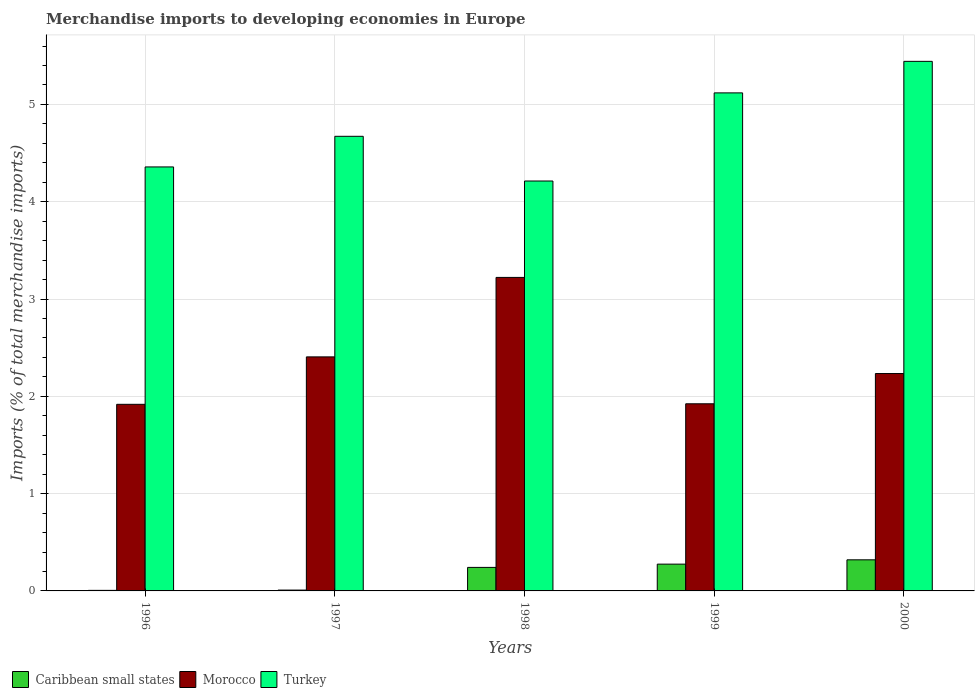How many different coloured bars are there?
Give a very brief answer. 3. How many bars are there on the 5th tick from the right?
Offer a very short reply. 3. What is the percentage total merchandise imports in Morocco in 1999?
Ensure brevity in your answer.  1.92. Across all years, what is the maximum percentage total merchandise imports in Turkey?
Provide a short and direct response. 5.44. Across all years, what is the minimum percentage total merchandise imports in Morocco?
Your response must be concise. 1.92. What is the total percentage total merchandise imports in Turkey in the graph?
Make the answer very short. 23.81. What is the difference between the percentage total merchandise imports in Morocco in 1996 and that in 1997?
Offer a terse response. -0.49. What is the difference between the percentage total merchandise imports in Turkey in 2000 and the percentage total merchandise imports in Morocco in 1999?
Ensure brevity in your answer.  3.52. What is the average percentage total merchandise imports in Morocco per year?
Offer a terse response. 2.34. In the year 1999, what is the difference between the percentage total merchandise imports in Caribbean small states and percentage total merchandise imports in Morocco?
Offer a very short reply. -1.65. In how many years, is the percentage total merchandise imports in Morocco greater than 4 %?
Ensure brevity in your answer.  0. What is the ratio of the percentage total merchandise imports in Turkey in 1996 to that in 1997?
Make the answer very short. 0.93. Is the percentage total merchandise imports in Morocco in 1996 less than that in 1999?
Your answer should be very brief. Yes. Is the difference between the percentage total merchandise imports in Caribbean small states in 1997 and 1999 greater than the difference between the percentage total merchandise imports in Morocco in 1997 and 1999?
Your answer should be very brief. No. What is the difference between the highest and the second highest percentage total merchandise imports in Turkey?
Your response must be concise. 0.32. What is the difference between the highest and the lowest percentage total merchandise imports in Caribbean small states?
Make the answer very short. 0.31. In how many years, is the percentage total merchandise imports in Caribbean small states greater than the average percentage total merchandise imports in Caribbean small states taken over all years?
Give a very brief answer. 3. Is the sum of the percentage total merchandise imports in Morocco in 1996 and 1997 greater than the maximum percentage total merchandise imports in Turkey across all years?
Your response must be concise. No. What does the 1st bar from the left in 2000 represents?
Provide a short and direct response. Caribbean small states. What does the 2nd bar from the right in 1997 represents?
Your response must be concise. Morocco. Is it the case that in every year, the sum of the percentage total merchandise imports in Caribbean small states and percentage total merchandise imports in Turkey is greater than the percentage total merchandise imports in Morocco?
Ensure brevity in your answer.  Yes. How many bars are there?
Offer a very short reply. 15. Are all the bars in the graph horizontal?
Provide a succinct answer. No. How many years are there in the graph?
Provide a succinct answer. 5. What is the difference between two consecutive major ticks on the Y-axis?
Keep it short and to the point. 1. Where does the legend appear in the graph?
Keep it short and to the point. Bottom left. How many legend labels are there?
Provide a short and direct response. 3. How are the legend labels stacked?
Give a very brief answer. Horizontal. What is the title of the graph?
Offer a very short reply. Merchandise imports to developing economies in Europe. Does "Botswana" appear as one of the legend labels in the graph?
Your answer should be very brief. No. What is the label or title of the Y-axis?
Offer a terse response. Imports (% of total merchandise imports). What is the Imports (% of total merchandise imports) in Caribbean small states in 1996?
Give a very brief answer. 0.01. What is the Imports (% of total merchandise imports) of Morocco in 1996?
Make the answer very short. 1.92. What is the Imports (% of total merchandise imports) in Turkey in 1996?
Offer a very short reply. 4.36. What is the Imports (% of total merchandise imports) of Caribbean small states in 1997?
Your response must be concise. 0.01. What is the Imports (% of total merchandise imports) in Morocco in 1997?
Provide a short and direct response. 2.41. What is the Imports (% of total merchandise imports) of Turkey in 1997?
Make the answer very short. 4.67. What is the Imports (% of total merchandise imports) of Caribbean small states in 1998?
Your answer should be very brief. 0.24. What is the Imports (% of total merchandise imports) in Morocco in 1998?
Provide a short and direct response. 3.22. What is the Imports (% of total merchandise imports) in Turkey in 1998?
Provide a succinct answer. 4.21. What is the Imports (% of total merchandise imports) in Caribbean small states in 1999?
Your response must be concise. 0.28. What is the Imports (% of total merchandise imports) of Morocco in 1999?
Your response must be concise. 1.92. What is the Imports (% of total merchandise imports) in Turkey in 1999?
Make the answer very short. 5.12. What is the Imports (% of total merchandise imports) in Caribbean small states in 2000?
Make the answer very short. 0.32. What is the Imports (% of total merchandise imports) in Morocco in 2000?
Your answer should be very brief. 2.23. What is the Imports (% of total merchandise imports) in Turkey in 2000?
Your response must be concise. 5.44. Across all years, what is the maximum Imports (% of total merchandise imports) of Caribbean small states?
Offer a very short reply. 0.32. Across all years, what is the maximum Imports (% of total merchandise imports) in Morocco?
Your response must be concise. 3.22. Across all years, what is the maximum Imports (% of total merchandise imports) of Turkey?
Your answer should be very brief. 5.44. Across all years, what is the minimum Imports (% of total merchandise imports) in Caribbean small states?
Provide a short and direct response. 0.01. Across all years, what is the minimum Imports (% of total merchandise imports) of Morocco?
Your response must be concise. 1.92. Across all years, what is the minimum Imports (% of total merchandise imports) of Turkey?
Offer a very short reply. 4.21. What is the total Imports (% of total merchandise imports) of Caribbean small states in the graph?
Give a very brief answer. 0.85. What is the total Imports (% of total merchandise imports) in Morocco in the graph?
Offer a terse response. 11.7. What is the total Imports (% of total merchandise imports) of Turkey in the graph?
Your response must be concise. 23.81. What is the difference between the Imports (% of total merchandise imports) in Caribbean small states in 1996 and that in 1997?
Your answer should be compact. -0. What is the difference between the Imports (% of total merchandise imports) in Morocco in 1996 and that in 1997?
Your response must be concise. -0.49. What is the difference between the Imports (% of total merchandise imports) in Turkey in 1996 and that in 1997?
Make the answer very short. -0.31. What is the difference between the Imports (% of total merchandise imports) of Caribbean small states in 1996 and that in 1998?
Your answer should be very brief. -0.24. What is the difference between the Imports (% of total merchandise imports) of Morocco in 1996 and that in 1998?
Make the answer very short. -1.3. What is the difference between the Imports (% of total merchandise imports) in Turkey in 1996 and that in 1998?
Your answer should be compact. 0.14. What is the difference between the Imports (% of total merchandise imports) of Caribbean small states in 1996 and that in 1999?
Ensure brevity in your answer.  -0.27. What is the difference between the Imports (% of total merchandise imports) of Morocco in 1996 and that in 1999?
Keep it short and to the point. -0.01. What is the difference between the Imports (% of total merchandise imports) in Turkey in 1996 and that in 1999?
Give a very brief answer. -0.76. What is the difference between the Imports (% of total merchandise imports) of Caribbean small states in 1996 and that in 2000?
Keep it short and to the point. -0.31. What is the difference between the Imports (% of total merchandise imports) of Morocco in 1996 and that in 2000?
Provide a succinct answer. -0.32. What is the difference between the Imports (% of total merchandise imports) of Turkey in 1996 and that in 2000?
Provide a short and direct response. -1.09. What is the difference between the Imports (% of total merchandise imports) in Caribbean small states in 1997 and that in 1998?
Offer a very short reply. -0.23. What is the difference between the Imports (% of total merchandise imports) of Morocco in 1997 and that in 1998?
Your response must be concise. -0.82. What is the difference between the Imports (% of total merchandise imports) of Turkey in 1997 and that in 1998?
Provide a short and direct response. 0.46. What is the difference between the Imports (% of total merchandise imports) in Caribbean small states in 1997 and that in 1999?
Give a very brief answer. -0.27. What is the difference between the Imports (% of total merchandise imports) of Morocco in 1997 and that in 1999?
Offer a terse response. 0.48. What is the difference between the Imports (% of total merchandise imports) of Turkey in 1997 and that in 1999?
Keep it short and to the point. -0.45. What is the difference between the Imports (% of total merchandise imports) of Caribbean small states in 1997 and that in 2000?
Offer a terse response. -0.31. What is the difference between the Imports (% of total merchandise imports) in Morocco in 1997 and that in 2000?
Keep it short and to the point. 0.17. What is the difference between the Imports (% of total merchandise imports) of Turkey in 1997 and that in 2000?
Ensure brevity in your answer.  -0.77. What is the difference between the Imports (% of total merchandise imports) of Caribbean small states in 1998 and that in 1999?
Offer a very short reply. -0.03. What is the difference between the Imports (% of total merchandise imports) in Morocco in 1998 and that in 1999?
Your answer should be compact. 1.3. What is the difference between the Imports (% of total merchandise imports) of Turkey in 1998 and that in 1999?
Make the answer very short. -0.91. What is the difference between the Imports (% of total merchandise imports) in Caribbean small states in 1998 and that in 2000?
Your answer should be very brief. -0.08. What is the difference between the Imports (% of total merchandise imports) in Morocco in 1998 and that in 2000?
Your answer should be compact. 0.99. What is the difference between the Imports (% of total merchandise imports) in Turkey in 1998 and that in 2000?
Your answer should be compact. -1.23. What is the difference between the Imports (% of total merchandise imports) of Caribbean small states in 1999 and that in 2000?
Offer a very short reply. -0.04. What is the difference between the Imports (% of total merchandise imports) in Morocco in 1999 and that in 2000?
Offer a terse response. -0.31. What is the difference between the Imports (% of total merchandise imports) of Turkey in 1999 and that in 2000?
Your response must be concise. -0.32. What is the difference between the Imports (% of total merchandise imports) of Caribbean small states in 1996 and the Imports (% of total merchandise imports) of Morocco in 1997?
Provide a short and direct response. -2.4. What is the difference between the Imports (% of total merchandise imports) of Caribbean small states in 1996 and the Imports (% of total merchandise imports) of Turkey in 1997?
Your response must be concise. -4.67. What is the difference between the Imports (% of total merchandise imports) in Morocco in 1996 and the Imports (% of total merchandise imports) in Turkey in 1997?
Your answer should be very brief. -2.75. What is the difference between the Imports (% of total merchandise imports) in Caribbean small states in 1996 and the Imports (% of total merchandise imports) in Morocco in 1998?
Your answer should be very brief. -3.22. What is the difference between the Imports (% of total merchandise imports) of Caribbean small states in 1996 and the Imports (% of total merchandise imports) of Turkey in 1998?
Keep it short and to the point. -4.21. What is the difference between the Imports (% of total merchandise imports) in Morocco in 1996 and the Imports (% of total merchandise imports) in Turkey in 1998?
Offer a very short reply. -2.3. What is the difference between the Imports (% of total merchandise imports) in Caribbean small states in 1996 and the Imports (% of total merchandise imports) in Morocco in 1999?
Ensure brevity in your answer.  -1.92. What is the difference between the Imports (% of total merchandise imports) in Caribbean small states in 1996 and the Imports (% of total merchandise imports) in Turkey in 1999?
Your answer should be compact. -5.11. What is the difference between the Imports (% of total merchandise imports) in Morocco in 1996 and the Imports (% of total merchandise imports) in Turkey in 1999?
Ensure brevity in your answer.  -3.2. What is the difference between the Imports (% of total merchandise imports) in Caribbean small states in 1996 and the Imports (% of total merchandise imports) in Morocco in 2000?
Provide a succinct answer. -2.23. What is the difference between the Imports (% of total merchandise imports) of Caribbean small states in 1996 and the Imports (% of total merchandise imports) of Turkey in 2000?
Your response must be concise. -5.44. What is the difference between the Imports (% of total merchandise imports) of Morocco in 1996 and the Imports (% of total merchandise imports) of Turkey in 2000?
Your answer should be compact. -3.53. What is the difference between the Imports (% of total merchandise imports) in Caribbean small states in 1997 and the Imports (% of total merchandise imports) in Morocco in 1998?
Ensure brevity in your answer.  -3.21. What is the difference between the Imports (% of total merchandise imports) of Caribbean small states in 1997 and the Imports (% of total merchandise imports) of Turkey in 1998?
Your answer should be very brief. -4.2. What is the difference between the Imports (% of total merchandise imports) of Morocco in 1997 and the Imports (% of total merchandise imports) of Turkey in 1998?
Provide a succinct answer. -1.81. What is the difference between the Imports (% of total merchandise imports) of Caribbean small states in 1997 and the Imports (% of total merchandise imports) of Morocco in 1999?
Provide a succinct answer. -1.91. What is the difference between the Imports (% of total merchandise imports) in Caribbean small states in 1997 and the Imports (% of total merchandise imports) in Turkey in 1999?
Keep it short and to the point. -5.11. What is the difference between the Imports (% of total merchandise imports) of Morocco in 1997 and the Imports (% of total merchandise imports) of Turkey in 1999?
Give a very brief answer. -2.71. What is the difference between the Imports (% of total merchandise imports) of Caribbean small states in 1997 and the Imports (% of total merchandise imports) of Morocco in 2000?
Provide a succinct answer. -2.23. What is the difference between the Imports (% of total merchandise imports) in Caribbean small states in 1997 and the Imports (% of total merchandise imports) in Turkey in 2000?
Your answer should be compact. -5.43. What is the difference between the Imports (% of total merchandise imports) of Morocco in 1997 and the Imports (% of total merchandise imports) of Turkey in 2000?
Give a very brief answer. -3.04. What is the difference between the Imports (% of total merchandise imports) in Caribbean small states in 1998 and the Imports (% of total merchandise imports) in Morocco in 1999?
Keep it short and to the point. -1.68. What is the difference between the Imports (% of total merchandise imports) of Caribbean small states in 1998 and the Imports (% of total merchandise imports) of Turkey in 1999?
Offer a very short reply. -4.88. What is the difference between the Imports (% of total merchandise imports) in Morocco in 1998 and the Imports (% of total merchandise imports) in Turkey in 1999?
Offer a very short reply. -1.9. What is the difference between the Imports (% of total merchandise imports) in Caribbean small states in 1998 and the Imports (% of total merchandise imports) in Morocco in 2000?
Provide a succinct answer. -1.99. What is the difference between the Imports (% of total merchandise imports) in Caribbean small states in 1998 and the Imports (% of total merchandise imports) in Turkey in 2000?
Offer a very short reply. -5.2. What is the difference between the Imports (% of total merchandise imports) in Morocco in 1998 and the Imports (% of total merchandise imports) in Turkey in 2000?
Ensure brevity in your answer.  -2.22. What is the difference between the Imports (% of total merchandise imports) of Caribbean small states in 1999 and the Imports (% of total merchandise imports) of Morocco in 2000?
Provide a succinct answer. -1.96. What is the difference between the Imports (% of total merchandise imports) of Caribbean small states in 1999 and the Imports (% of total merchandise imports) of Turkey in 2000?
Keep it short and to the point. -5.17. What is the difference between the Imports (% of total merchandise imports) of Morocco in 1999 and the Imports (% of total merchandise imports) of Turkey in 2000?
Keep it short and to the point. -3.52. What is the average Imports (% of total merchandise imports) in Caribbean small states per year?
Your answer should be very brief. 0.17. What is the average Imports (% of total merchandise imports) of Morocco per year?
Make the answer very short. 2.34. What is the average Imports (% of total merchandise imports) of Turkey per year?
Make the answer very short. 4.76. In the year 1996, what is the difference between the Imports (% of total merchandise imports) in Caribbean small states and Imports (% of total merchandise imports) in Morocco?
Offer a very short reply. -1.91. In the year 1996, what is the difference between the Imports (% of total merchandise imports) in Caribbean small states and Imports (% of total merchandise imports) in Turkey?
Your answer should be very brief. -4.35. In the year 1996, what is the difference between the Imports (% of total merchandise imports) in Morocco and Imports (% of total merchandise imports) in Turkey?
Keep it short and to the point. -2.44. In the year 1997, what is the difference between the Imports (% of total merchandise imports) of Caribbean small states and Imports (% of total merchandise imports) of Morocco?
Give a very brief answer. -2.4. In the year 1997, what is the difference between the Imports (% of total merchandise imports) in Caribbean small states and Imports (% of total merchandise imports) in Turkey?
Offer a very short reply. -4.66. In the year 1997, what is the difference between the Imports (% of total merchandise imports) of Morocco and Imports (% of total merchandise imports) of Turkey?
Provide a succinct answer. -2.27. In the year 1998, what is the difference between the Imports (% of total merchandise imports) in Caribbean small states and Imports (% of total merchandise imports) in Morocco?
Your answer should be compact. -2.98. In the year 1998, what is the difference between the Imports (% of total merchandise imports) in Caribbean small states and Imports (% of total merchandise imports) in Turkey?
Keep it short and to the point. -3.97. In the year 1998, what is the difference between the Imports (% of total merchandise imports) in Morocco and Imports (% of total merchandise imports) in Turkey?
Provide a succinct answer. -0.99. In the year 1999, what is the difference between the Imports (% of total merchandise imports) in Caribbean small states and Imports (% of total merchandise imports) in Morocco?
Ensure brevity in your answer.  -1.65. In the year 1999, what is the difference between the Imports (% of total merchandise imports) of Caribbean small states and Imports (% of total merchandise imports) of Turkey?
Your answer should be very brief. -4.84. In the year 1999, what is the difference between the Imports (% of total merchandise imports) of Morocco and Imports (% of total merchandise imports) of Turkey?
Your response must be concise. -3.2. In the year 2000, what is the difference between the Imports (% of total merchandise imports) in Caribbean small states and Imports (% of total merchandise imports) in Morocco?
Offer a very short reply. -1.91. In the year 2000, what is the difference between the Imports (% of total merchandise imports) in Caribbean small states and Imports (% of total merchandise imports) in Turkey?
Your answer should be compact. -5.12. In the year 2000, what is the difference between the Imports (% of total merchandise imports) of Morocco and Imports (% of total merchandise imports) of Turkey?
Your answer should be compact. -3.21. What is the ratio of the Imports (% of total merchandise imports) of Caribbean small states in 1996 to that in 1997?
Your response must be concise. 0.66. What is the ratio of the Imports (% of total merchandise imports) of Morocco in 1996 to that in 1997?
Keep it short and to the point. 0.8. What is the ratio of the Imports (% of total merchandise imports) of Turkey in 1996 to that in 1997?
Provide a short and direct response. 0.93. What is the ratio of the Imports (% of total merchandise imports) in Caribbean small states in 1996 to that in 1998?
Your answer should be compact. 0.02. What is the ratio of the Imports (% of total merchandise imports) in Morocco in 1996 to that in 1998?
Provide a succinct answer. 0.6. What is the ratio of the Imports (% of total merchandise imports) of Turkey in 1996 to that in 1998?
Keep it short and to the point. 1.03. What is the ratio of the Imports (% of total merchandise imports) of Caribbean small states in 1996 to that in 1999?
Your answer should be compact. 0.02. What is the ratio of the Imports (% of total merchandise imports) of Morocco in 1996 to that in 1999?
Give a very brief answer. 1. What is the ratio of the Imports (% of total merchandise imports) in Turkey in 1996 to that in 1999?
Make the answer very short. 0.85. What is the ratio of the Imports (% of total merchandise imports) of Caribbean small states in 1996 to that in 2000?
Your answer should be very brief. 0.02. What is the ratio of the Imports (% of total merchandise imports) of Morocco in 1996 to that in 2000?
Offer a very short reply. 0.86. What is the ratio of the Imports (% of total merchandise imports) of Turkey in 1996 to that in 2000?
Keep it short and to the point. 0.8. What is the ratio of the Imports (% of total merchandise imports) of Caribbean small states in 1997 to that in 1998?
Make the answer very short. 0.04. What is the ratio of the Imports (% of total merchandise imports) of Morocco in 1997 to that in 1998?
Your answer should be very brief. 0.75. What is the ratio of the Imports (% of total merchandise imports) of Turkey in 1997 to that in 1998?
Your answer should be compact. 1.11. What is the ratio of the Imports (% of total merchandise imports) in Caribbean small states in 1997 to that in 1999?
Make the answer very short. 0.03. What is the ratio of the Imports (% of total merchandise imports) of Morocco in 1997 to that in 1999?
Provide a short and direct response. 1.25. What is the ratio of the Imports (% of total merchandise imports) in Turkey in 1997 to that in 1999?
Provide a succinct answer. 0.91. What is the ratio of the Imports (% of total merchandise imports) in Caribbean small states in 1997 to that in 2000?
Offer a terse response. 0.03. What is the ratio of the Imports (% of total merchandise imports) in Morocco in 1997 to that in 2000?
Provide a succinct answer. 1.08. What is the ratio of the Imports (% of total merchandise imports) of Turkey in 1997 to that in 2000?
Offer a terse response. 0.86. What is the ratio of the Imports (% of total merchandise imports) in Caribbean small states in 1998 to that in 1999?
Keep it short and to the point. 0.88. What is the ratio of the Imports (% of total merchandise imports) in Morocco in 1998 to that in 1999?
Offer a very short reply. 1.68. What is the ratio of the Imports (% of total merchandise imports) in Turkey in 1998 to that in 1999?
Give a very brief answer. 0.82. What is the ratio of the Imports (% of total merchandise imports) in Caribbean small states in 1998 to that in 2000?
Keep it short and to the point. 0.76. What is the ratio of the Imports (% of total merchandise imports) of Morocco in 1998 to that in 2000?
Give a very brief answer. 1.44. What is the ratio of the Imports (% of total merchandise imports) in Turkey in 1998 to that in 2000?
Provide a succinct answer. 0.77. What is the ratio of the Imports (% of total merchandise imports) of Caribbean small states in 1999 to that in 2000?
Make the answer very short. 0.86. What is the ratio of the Imports (% of total merchandise imports) of Morocco in 1999 to that in 2000?
Your answer should be compact. 0.86. What is the ratio of the Imports (% of total merchandise imports) in Turkey in 1999 to that in 2000?
Make the answer very short. 0.94. What is the difference between the highest and the second highest Imports (% of total merchandise imports) of Caribbean small states?
Your answer should be compact. 0.04. What is the difference between the highest and the second highest Imports (% of total merchandise imports) of Morocco?
Offer a very short reply. 0.82. What is the difference between the highest and the second highest Imports (% of total merchandise imports) in Turkey?
Give a very brief answer. 0.32. What is the difference between the highest and the lowest Imports (% of total merchandise imports) of Caribbean small states?
Your response must be concise. 0.31. What is the difference between the highest and the lowest Imports (% of total merchandise imports) in Morocco?
Ensure brevity in your answer.  1.3. What is the difference between the highest and the lowest Imports (% of total merchandise imports) of Turkey?
Your answer should be compact. 1.23. 